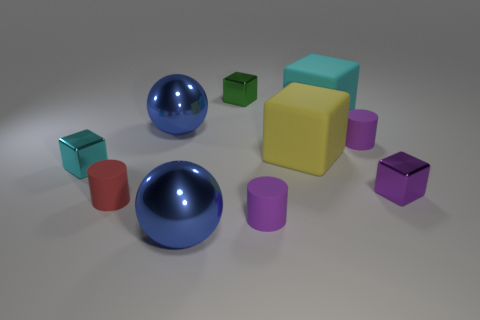Do the red cylinder and the big yellow object have the same material?
Keep it short and to the point. Yes. Is there anything else that is the same shape as the big yellow object?
Your answer should be very brief. Yes. There is a large cyan object behind the tiny shiny block to the left of the tiny green cube; what is its material?
Give a very brief answer. Rubber. What size is the blue sphere behind the big yellow matte block?
Your answer should be very brief. Large. The object that is in front of the big yellow cube and to the right of the cyan matte thing is what color?
Your answer should be very brief. Purple. There is a cylinder behind the purple metal cube; does it have the same size as the red rubber cylinder?
Provide a short and direct response. Yes. Is there a cube that is to the right of the big blue thing in front of the tiny red thing?
Keep it short and to the point. Yes. What is the material of the tiny red object?
Give a very brief answer. Rubber. Are there any rubber cubes in front of the cyan matte cube?
Give a very brief answer. Yes. What size is the yellow thing that is the same shape as the green thing?
Your answer should be compact. Large. 